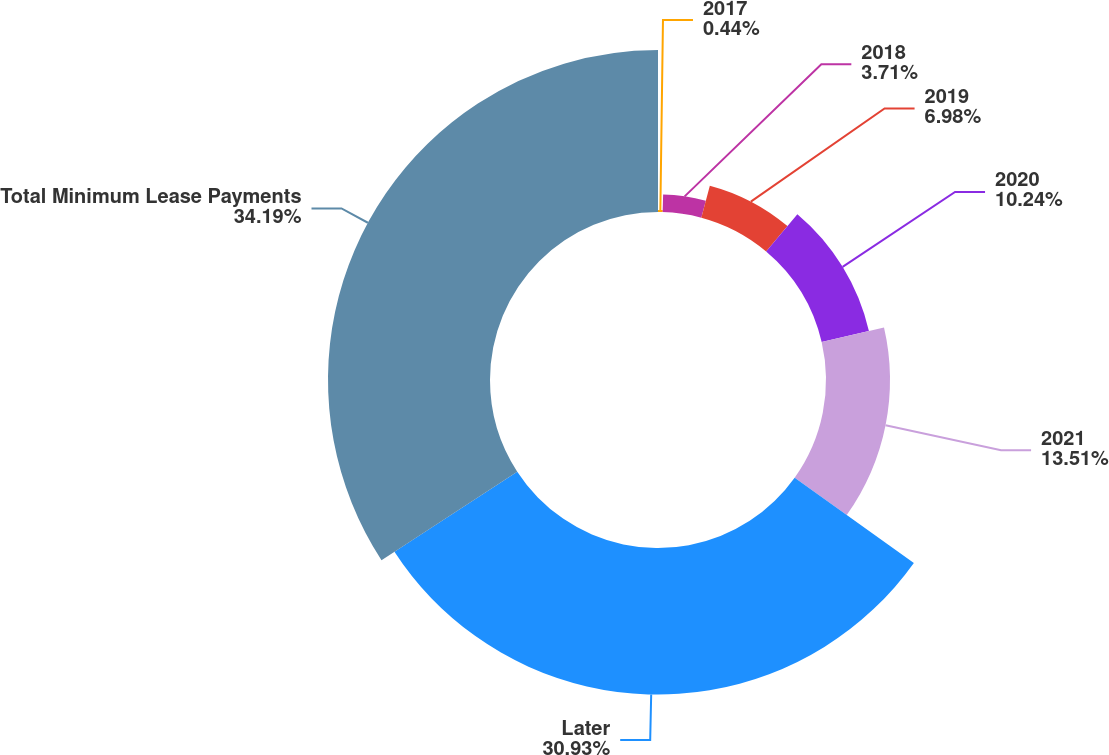Convert chart to OTSL. <chart><loc_0><loc_0><loc_500><loc_500><pie_chart><fcel>2017<fcel>2018<fcel>2019<fcel>2020<fcel>2021<fcel>Later<fcel>Total Minimum Lease Payments<nl><fcel>0.44%<fcel>3.71%<fcel>6.98%<fcel>10.24%<fcel>13.51%<fcel>30.93%<fcel>34.19%<nl></chart> 